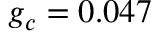Convert formula to latex. <formula><loc_0><loc_0><loc_500><loc_500>g _ { c } = 0 . 0 4 7</formula> 